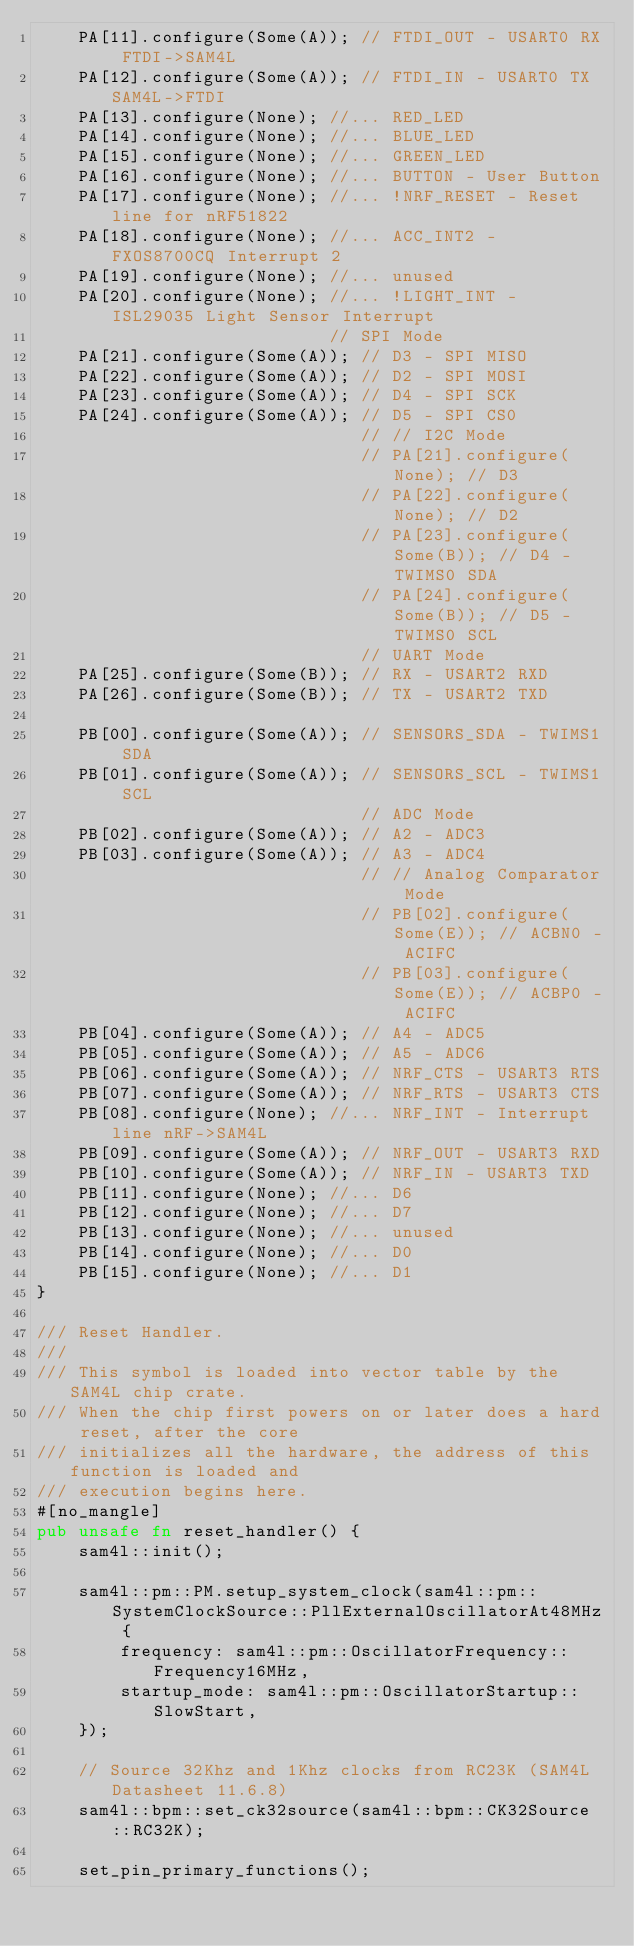Convert code to text. <code><loc_0><loc_0><loc_500><loc_500><_Rust_>    PA[11].configure(Some(A)); // FTDI_OUT - USART0 RX FTDI->SAM4L
    PA[12].configure(Some(A)); // FTDI_IN - USART0 TX SAM4L->FTDI
    PA[13].configure(None); //... RED_LED
    PA[14].configure(None); //... BLUE_LED
    PA[15].configure(None); //... GREEN_LED
    PA[16].configure(None); //... BUTTON - User Button
    PA[17].configure(None); //... !NRF_RESET - Reset line for nRF51822
    PA[18].configure(None); //... ACC_INT2 - FXOS8700CQ Interrupt 2
    PA[19].configure(None); //... unused
    PA[20].configure(None); //... !LIGHT_INT - ISL29035 Light Sensor Interrupt
                            // SPI Mode
    PA[21].configure(Some(A)); // D3 - SPI MISO
    PA[22].configure(Some(A)); // D2 - SPI MOSI
    PA[23].configure(Some(A)); // D4 - SPI SCK
    PA[24].configure(Some(A)); // D5 - SPI CS0
                               // // I2C Mode
                               // PA[21].configure(None); // D3
                               // PA[22].configure(None); // D2
                               // PA[23].configure(Some(B)); // D4 - TWIMS0 SDA
                               // PA[24].configure(Some(B)); // D5 - TWIMS0 SCL
                               // UART Mode
    PA[25].configure(Some(B)); // RX - USART2 RXD
    PA[26].configure(Some(B)); // TX - USART2 TXD

    PB[00].configure(Some(A)); // SENSORS_SDA - TWIMS1 SDA
    PB[01].configure(Some(A)); // SENSORS_SCL - TWIMS1 SCL
                               // ADC Mode
    PB[02].configure(Some(A)); // A2 - ADC3
    PB[03].configure(Some(A)); // A3 - ADC4
                               // // Analog Comparator Mode
                               // PB[02].configure(Some(E)); // ACBN0 - ACIFC
                               // PB[03].configure(Some(E)); // ACBP0 - ACIFC
    PB[04].configure(Some(A)); // A4 - ADC5
    PB[05].configure(Some(A)); // A5 - ADC6
    PB[06].configure(Some(A)); // NRF_CTS - USART3 RTS
    PB[07].configure(Some(A)); // NRF_RTS - USART3 CTS
    PB[08].configure(None); //... NRF_INT - Interrupt line nRF->SAM4L
    PB[09].configure(Some(A)); // NRF_OUT - USART3 RXD
    PB[10].configure(Some(A)); // NRF_IN - USART3 TXD
    PB[11].configure(None); //... D6
    PB[12].configure(None); //... D7
    PB[13].configure(None); //... unused
    PB[14].configure(None); //... D0
    PB[15].configure(None); //... D1
}

/// Reset Handler.
///
/// This symbol is loaded into vector table by the SAM4L chip crate.
/// When the chip first powers on or later does a hard reset, after the core
/// initializes all the hardware, the address of this function is loaded and
/// execution begins here.
#[no_mangle]
pub unsafe fn reset_handler() {
    sam4l::init();

    sam4l::pm::PM.setup_system_clock(sam4l::pm::SystemClockSource::PllExternalOscillatorAt48MHz {
        frequency: sam4l::pm::OscillatorFrequency::Frequency16MHz,
        startup_mode: sam4l::pm::OscillatorStartup::SlowStart,
    });

    // Source 32Khz and 1Khz clocks from RC23K (SAM4L Datasheet 11.6.8)
    sam4l::bpm::set_ck32source(sam4l::bpm::CK32Source::RC32K);

    set_pin_primary_functions();
</code> 